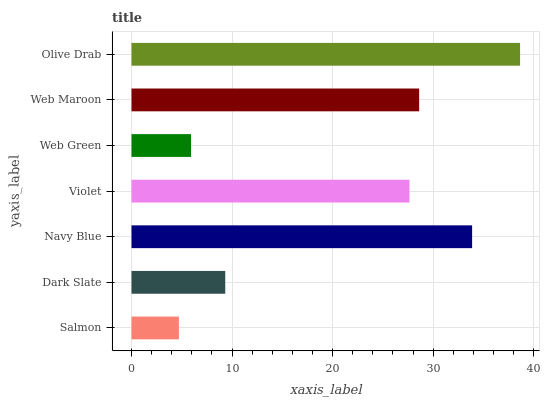Is Salmon the minimum?
Answer yes or no. Yes. Is Olive Drab the maximum?
Answer yes or no. Yes. Is Dark Slate the minimum?
Answer yes or no. No. Is Dark Slate the maximum?
Answer yes or no. No. Is Dark Slate greater than Salmon?
Answer yes or no. Yes. Is Salmon less than Dark Slate?
Answer yes or no. Yes. Is Salmon greater than Dark Slate?
Answer yes or no. No. Is Dark Slate less than Salmon?
Answer yes or no. No. Is Violet the high median?
Answer yes or no. Yes. Is Violet the low median?
Answer yes or no. Yes. Is Web Green the high median?
Answer yes or no. No. Is Olive Drab the low median?
Answer yes or no. No. 